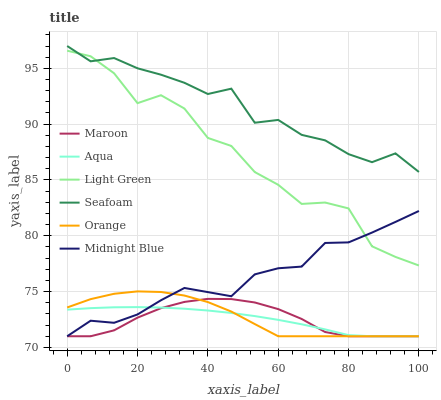Does Maroon have the minimum area under the curve?
Answer yes or no. Yes. Does Seafoam have the maximum area under the curve?
Answer yes or no. Yes. Does Aqua have the minimum area under the curve?
Answer yes or no. No. Does Aqua have the maximum area under the curve?
Answer yes or no. No. Is Aqua the smoothest?
Answer yes or no. Yes. Is Light Green the roughest?
Answer yes or no. Yes. Is Seafoam the smoothest?
Answer yes or no. No. Is Seafoam the roughest?
Answer yes or no. No. Does Midnight Blue have the lowest value?
Answer yes or no. Yes. Does Seafoam have the lowest value?
Answer yes or no. No. Does Seafoam have the highest value?
Answer yes or no. Yes. Does Aqua have the highest value?
Answer yes or no. No. Is Maroon less than Seafoam?
Answer yes or no. Yes. Is Light Green greater than Maroon?
Answer yes or no. Yes. Does Orange intersect Aqua?
Answer yes or no. Yes. Is Orange less than Aqua?
Answer yes or no. No. Is Orange greater than Aqua?
Answer yes or no. No. Does Maroon intersect Seafoam?
Answer yes or no. No. 